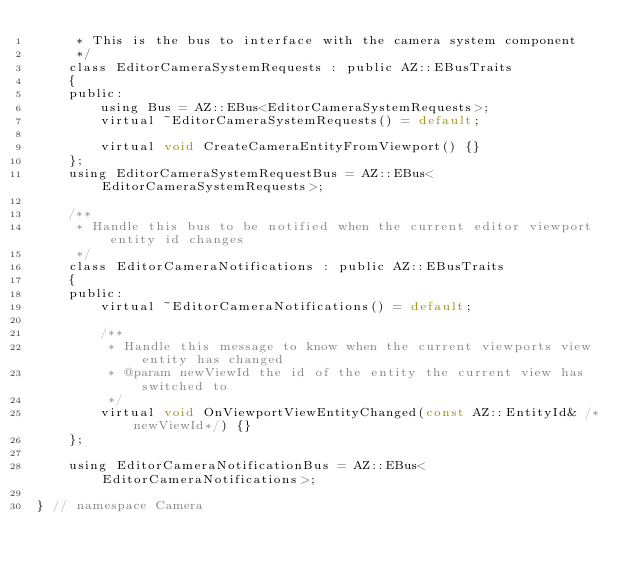Convert code to text. <code><loc_0><loc_0><loc_500><loc_500><_C_>     * This is the bus to interface with the camera system component
     */
    class EditorCameraSystemRequests : public AZ::EBusTraits
    {
    public:
        using Bus = AZ::EBus<EditorCameraSystemRequests>;
        virtual ~EditorCameraSystemRequests() = default;

        virtual void CreateCameraEntityFromViewport() {}
    };
    using EditorCameraSystemRequestBus = AZ::EBus<EditorCameraSystemRequests>;

    /**
     * Handle this bus to be notified when the current editor viewport entity id changes
     */
    class EditorCameraNotifications : public AZ::EBusTraits
    {
    public:
        virtual ~EditorCameraNotifications() = default;

        /**
         * Handle this message to know when the current viewports view entity has changed
         * @param newViewId the id of the entity the current view has switched to
         */
        virtual void OnViewportViewEntityChanged(const AZ::EntityId& /*newViewId*/) {}
    };

    using EditorCameraNotificationBus = AZ::EBus<EditorCameraNotifications>;

} // namespace Camera
</code> 